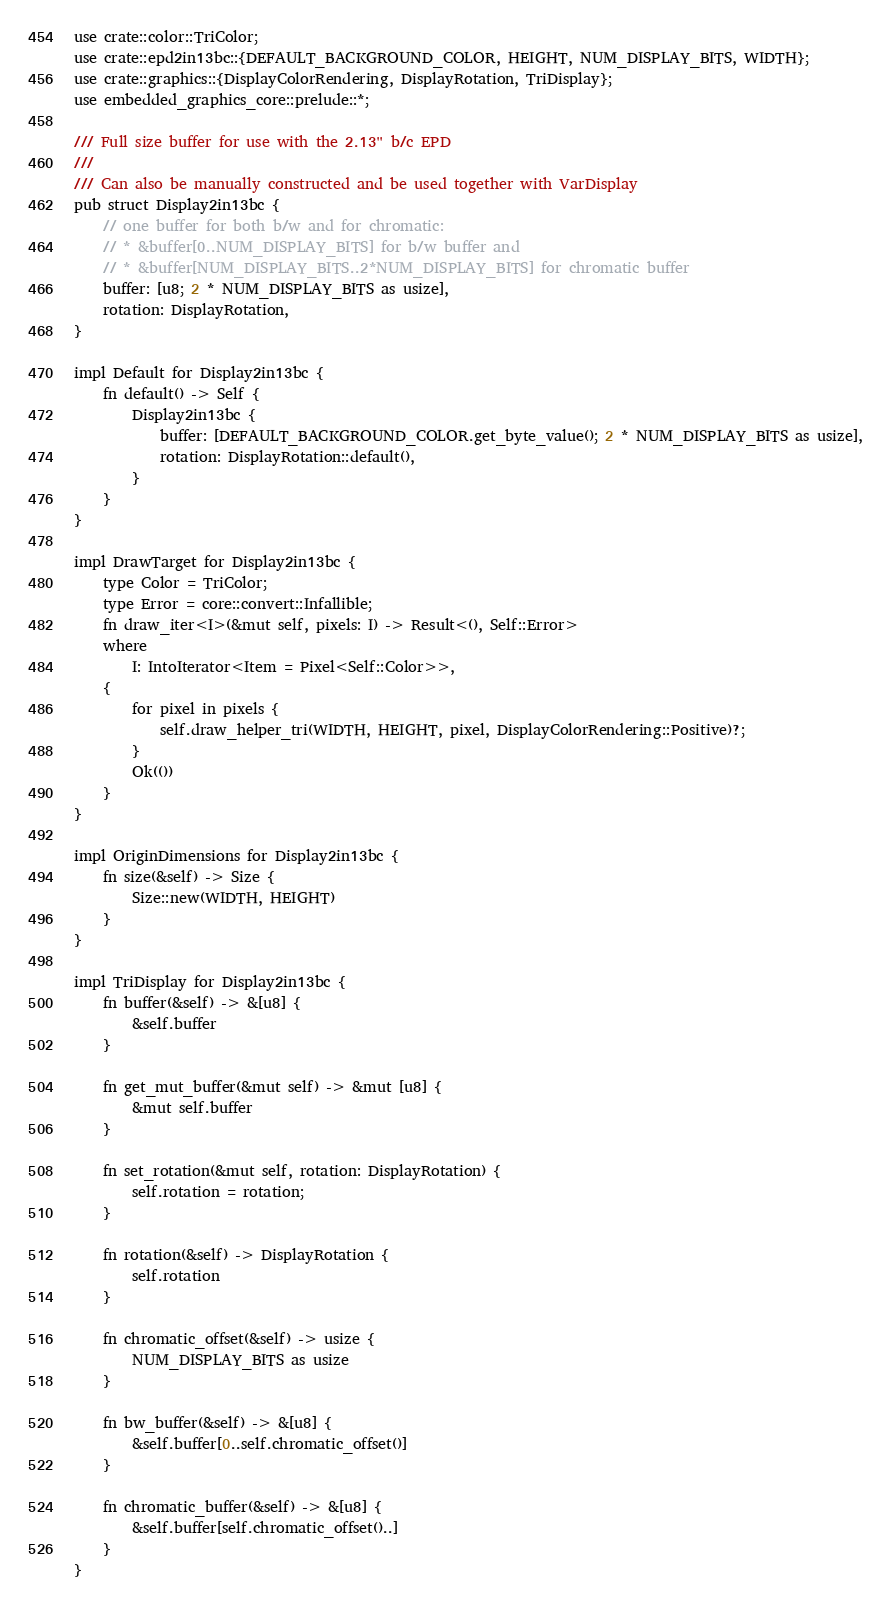<code> <loc_0><loc_0><loc_500><loc_500><_Rust_>use crate::color::TriColor;
use crate::epd2in13bc::{DEFAULT_BACKGROUND_COLOR, HEIGHT, NUM_DISPLAY_BITS, WIDTH};
use crate::graphics::{DisplayColorRendering, DisplayRotation, TriDisplay};
use embedded_graphics_core::prelude::*;

/// Full size buffer for use with the 2.13" b/c EPD
///
/// Can also be manually constructed and be used together with VarDisplay
pub struct Display2in13bc {
    // one buffer for both b/w and for chromatic:
    // * &buffer[0..NUM_DISPLAY_BITS] for b/w buffer and
    // * &buffer[NUM_DISPLAY_BITS..2*NUM_DISPLAY_BITS] for chromatic buffer
    buffer: [u8; 2 * NUM_DISPLAY_BITS as usize],
    rotation: DisplayRotation,
}

impl Default for Display2in13bc {
    fn default() -> Self {
        Display2in13bc {
            buffer: [DEFAULT_BACKGROUND_COLOR.get_byte_value(); 2 * NUM_DISPLAY_BITS as usize],
            rotation: DisplayRotation::default(),
        }
    }
}

impl DrawTarget for Display2in13bc {
    type Color = TriColor;
    type Error = core::convert::Infallible;
    fn draw_iter<I>(&mut self, pixels: I) -> Result<(), Self::Error>
    where
        I: IntoIterator<Item = Pixel<Self::Color>>,
    {
        for pixel in pixels {
            self.draw_helper_tri(WIDTH, HEIGHT, pixel, DisplayColorRendering::Positive)?;
        }
        Ok(())
    }
}

impl OriginDimensions for Display2in13bc {
    fn size(&self) -> Size {
        Size::new(WIDTH, HEIGHT)
    }
}

impl TriDisplay for Display2in13bc {
    fn buffer(&self) -> &[u8] {
        &self.buffer
    }

    fn get_mut_buffer(&mut self) -> &mut [u8] {
        &mut self.buffer
    }

    fn set_rotation(&mut self, rotation: DisplayRotation) {
        self.rotation = rotation;
    }

    fn rotation(&self) -> DisplayRotation {
        self.rotation
    }

    fn chromatic_offset(&self) -> usize {
        NUM_DISPLAY_BITS as usize
    }

    fn bw_buffer(&self) -> &[u8] {
        &self.buffer[0..self.chromatic_offset()]
    }

    fn chromatic_buffer(&self) -> &[u8] {
        &self.buffer[self.chromatic_offset()..]
    }
}
</code> 